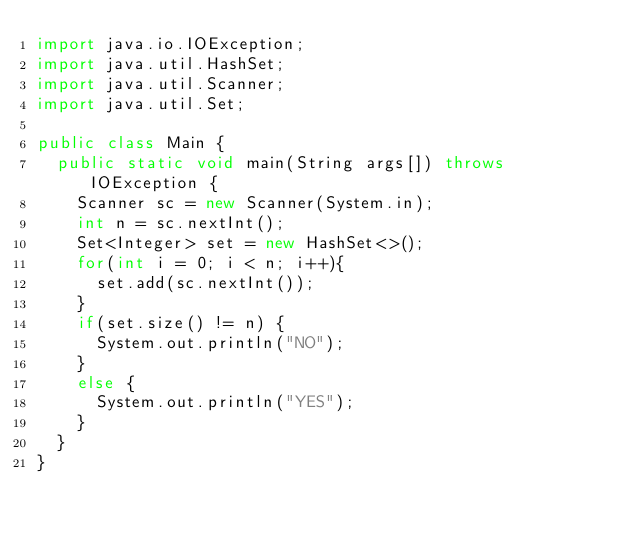<code> <loc_0><loc_0><loc_500><loc_500><_Java_>import java.io.IOException;
import java.util.HashSet;
import java.util.Scanner;
import java.util.Set;

public class Main {
	public static void main(String args[]) throws IOException {
		Scanner sc = new Scanner(System.in);
		int n = sc.nextInt();
		Set<Integer> set = new HashSet<>();
		for(int i = 0; i < n; i++){
			set.add(sc.nextInt());
		}
		if(set.size() != n) {
			System.out.println("NO");
		}
		else {
			System.out.println("YES");
		}
	}
}
</code> 